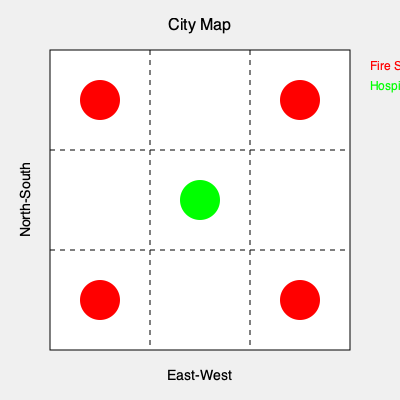Based on the color-coded map of emergency services distribution in the city, what is the most urgent improvement needed to enhance the city's emergency response capabilities? To analyze the distribution of emergency services and determine the most urgent improvement, let's follow these steps:

1. Identify the services shown:
   - Red circles represent fire stations
   - Green circle represents a hospital

2. Analyze the distribution:
   - Fire stations are located in the four corners of the city
   - The hospital is centrally located

3. Consider coverage:
   - Fire stations provide good coverage to the outer areas
   - The hospital is well-positioned for central access

4. Identify gaps:
   - There's only one hospital for the entire city
   - No emergency services in the mid-sections between corners

5. Assess response times:
   - Fire response should be quick to most areas
   - Medical emergencies in outer areas may face longer response times

6. Prioritize improvements:
   - Adding more hospitals would improve overall emergency medical coverage
   - Placing additional emergency medical services (EMS) stations in mid-sections could reduce response times

7. Consider the mayor's priorities:
   - As a mayor focused on resident welfare and safety, addressing medical emergency response is crucial

Given these factors, the most urgent improvement would be to add more medical emergency facilities, either additional hospitals or EMS stations, to complement the existing hospital and improve response times across the city.
Answer: Add more hospitals or EMS stations 